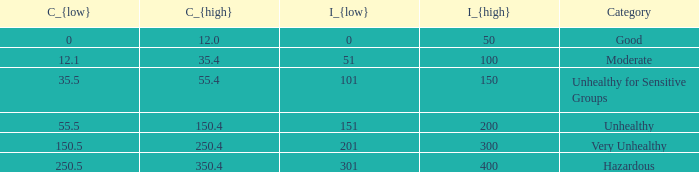What is the value of c_{low} when c_{high} equals 12.0? 0.0. 